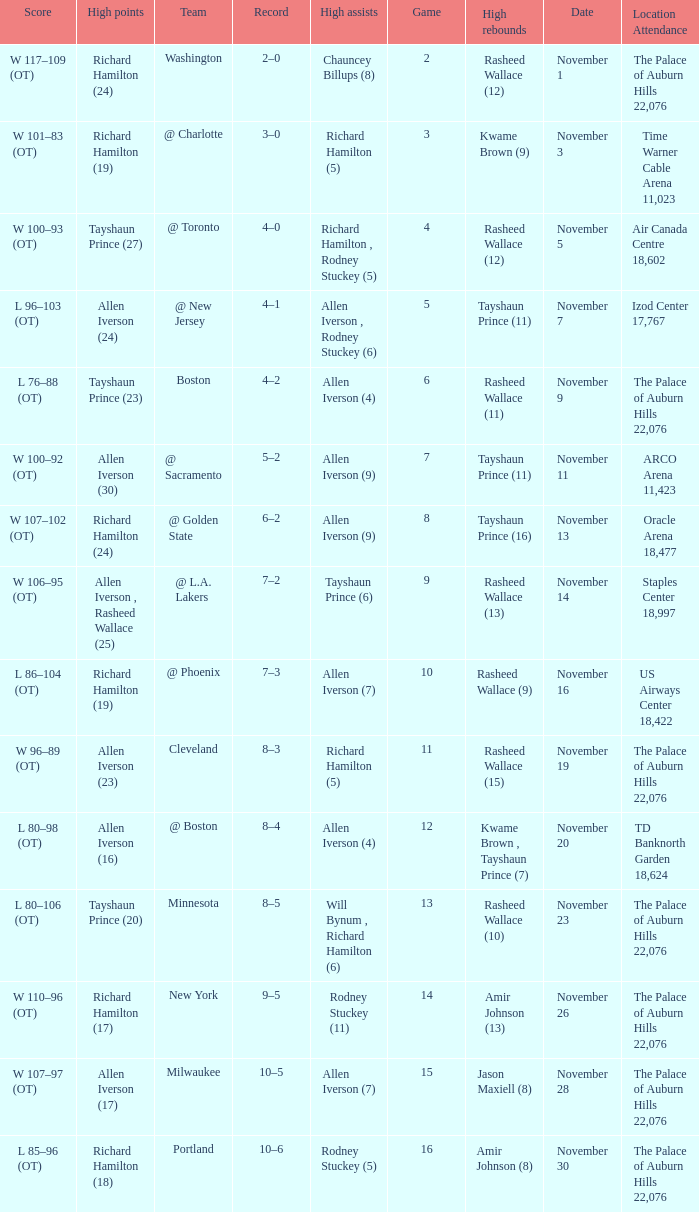What is the average Game, when Team is "Milwaukee"? 15.0. 